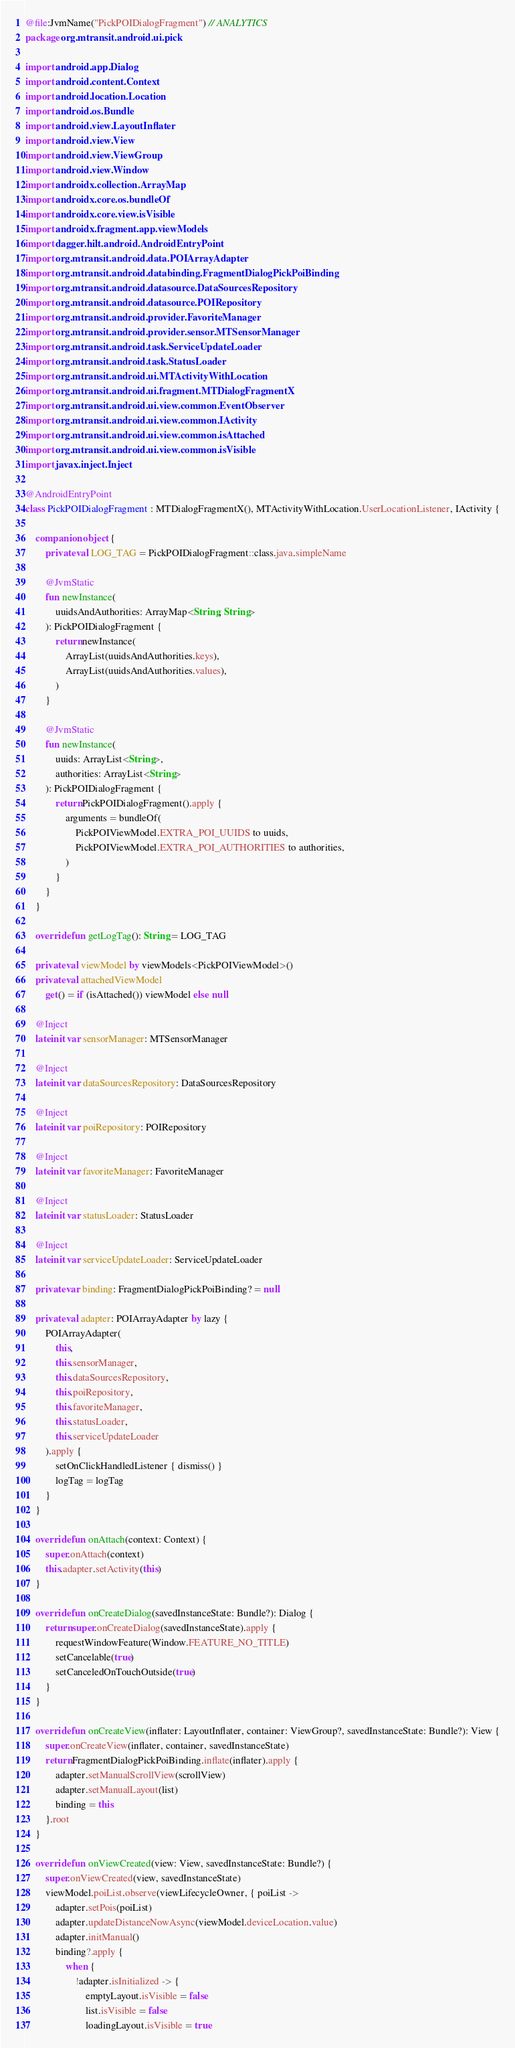<code> <loc_0><loc_0><loc_500><loc_500><_Kotlin_>@file:JvmName("PickPOIDialogFragment") // ANALYTICS
package org.mtransit.android.ui.pick

import android.app.Dialog
import android.content.Context
import android.location.Location
import android.os.Bundle
import android.view.LayoutInflater
import android.view.View
import android.view.ViewGroup
import android.view.Window
import androidx.collection.ArrayMap
import androidx.core.os.bundleOf
import androidx.core.view.isVisible
import androidx.fragment.app.viewModels
import dagger.hilt.android.AndroidEntryPoint
import org.mtransit.android.data.POIArrayAdapter
import org.mtransit.android.databinding.FragmentDialogPickPoiBinding
import org.mtransit.android.datasource.DataSourcesRepository
import org.mtransit.android.datasource.POIRepository
import org.mtransit.android.provider.FavoriteManager
import org.mtransit.android.provider.sensor.MTSensorManager
import org.mtransit.android.task.ServiceUpdateLoader
import org.mtransit.android.task.StatusLoader
import org.mtransit.android.ui.MTActivityWithLocation
import org.mtransit.android.ui.fragment.MTDialogFragmentX
import org.mtransit.android.ui.view.common.EventObserver
import org.mtransit.android.ui.view.common.IActivity
import org.mtransit.android.ui.view.common.isAttached
import org.mtransit.android.ui.view.common.isVisible
import javax.inject.Inject

@AndroidEntryPoint
class PickPOIDialogFragment : MTDialogFragmentX(), MTActivityWithLocation.UserLocationListener, IActivity {

    companion object {
        private val LOG_TAG = PickPOIDialogFragment::class.java.simpleName

        @JvmStatic
        fun newInstance(
            uuidsAndAuthorities: ArrayMap<String, String>
        ): PickPOIDialogFragment {
            return newInstance(
                ArrayList(uuidsAndAuthorities.keys),
                ArrayList(uuidsAndAuthorities.values),
            )
        }

        @JvmStatic
        fun newInstance(
            uuids: ArrayList<String>,
            authorities: ArrayList<String>
        ): PickPOIDialogFragment {
            return PickPOIDialogFragment().apply {
                arguments = bundleOf(
                    PickPOIViewModel.EXTRA_POI_UUIDS to uuids,
                    PickPOIViewModel.EXTRA_POI_AUTHORITIES to authorities,
                )
            }
        }
    }

    override fun getLogTag(): String = LOG_TAG

    private val viewModel by viewModels<PickPOIViewModel>()
    private val attachedViewModel
        get() = if (isAttached()) viewModel else null

    @Inject
    lateinit var sensorManager: MTSensorManager

    @Inject
    lateinit var dataSourcesRepository: DataSourcesRepository

    @Inject
    lateinit var poiRepository: POIRepository

    @Inject
    lateinit var favoriteManager: FavoriteManager

    @Inject
    lateinit var statusLoader: StatusLoader

    @Inject
    lateinit var serviceUpdateLoader: ServiceUpdateLoader

    private var binding: FragmentDialogPickPoiBinding? = null

    private val adapter: POIArrayAdapter by lazy {
        POIArrayAdapter(
            this,
            this.sensorManager,
            this.dataSourcesRepository,
            this.poiRepository,
            this.favoriteManager,
            this.statusLoader,
            this.serviceUpdateLoader
        ).apply {
            setOnClickHandledListener { dismiss() }
            logTag = logTag
        }
    }

    override fun onAttach(context: Context) {
        super.onAttach(context)
        this.adapter.setActivity(this)
    }

    override fun onCreateDialog(savedInstanceState: Bundle?): Dialog {
        return super.onCreateDialog(savedInstanceState).apply {
            requestWindowFeature(Window.FEATURE_NO_TITLE)
            setCancelable(true)
            setCanceledOnTouchOutside(true)
        }
    }

    override fun onCreateView(inflater: LayoutInflater, container: ViewGroup?, savedInstanceState: Bundle?): View {
        super.onCreateView(inflater, container, savedInstanceState)
        return FragmentDialogPickPoiBinding.inflate(inflater).apply {
            adapter.setManualScrollView(scrollView)
            adapter.setManualLayout(list)
            binding = this
        }.root
    }

    override fun onViewCreated(view: View, savedInstanceState: Bundle?) {
        super.onViewCreated(view, savedInstanceState)
        viewModel.poiList.observe(viewLifecycleOwner, { poiList ->
            adapter.setPois(poiList)
            adapter.updateDistanceNowAsync(viewModel.deviceLocation.value)
            adapter.initManual()
            binding?.apply {
                when {
                    !adapter.isInitialized -> {
                        emptyLayout.isVisible = false
                        list.isVisible = false
                        loadingLayout.isVisible = true</code> 